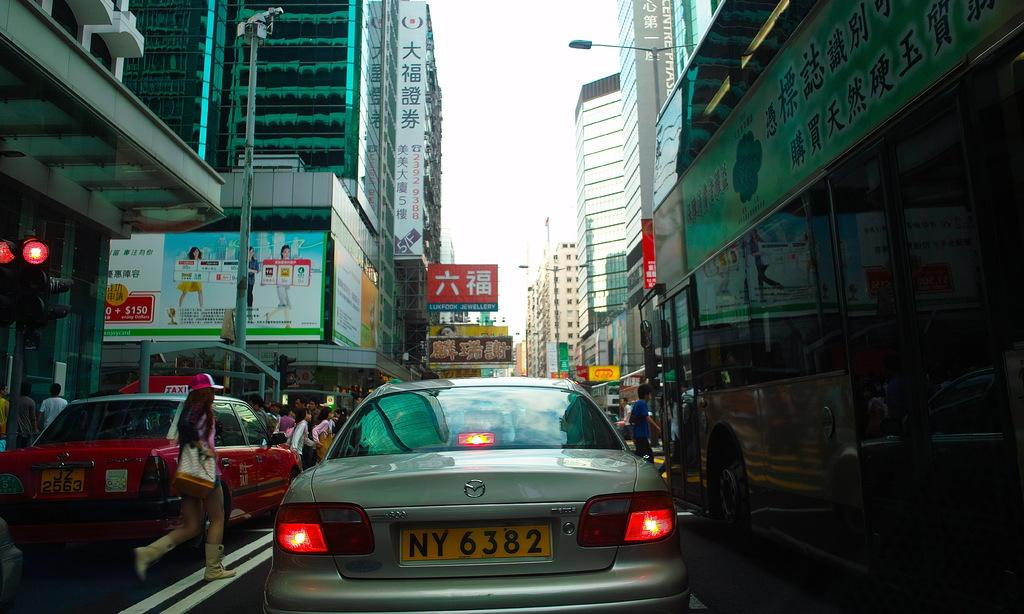<image>
Share a concise interpretation of the image provided. A car is in a busy street and has the letters NY on its plate. 